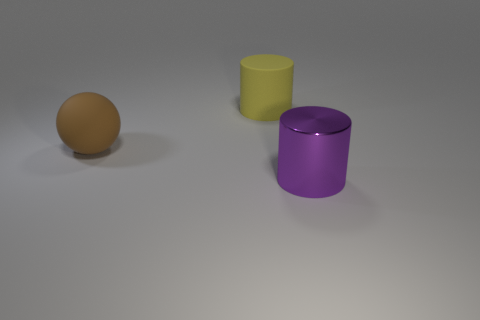Subtract all yellow cylinders. How many cylinders are left? 1 Subtract all spheres. How many objects are left? 2 Subtract all tiny yellow shiny cylinders. Subtract all large purple cylinders. How many objects are left? 2 Add 2 purple metallic things. How many purple metallic things are left? 3 Add 2 tiny yellow metallic cubes. How many tiny yellow metallic cubes exist? 2 Add 3 big yellow objects. How many objects exist? 6 Subtract 0 green blocks. How many objects are left? 3 Subtract 1 cylinders. How many cylinders are left? 1 Subtract all brown cylinders. Subtract all blue cubes. How many cylinders are left? 2 Subtract all red cylinders. How many gray balls are left? 0 